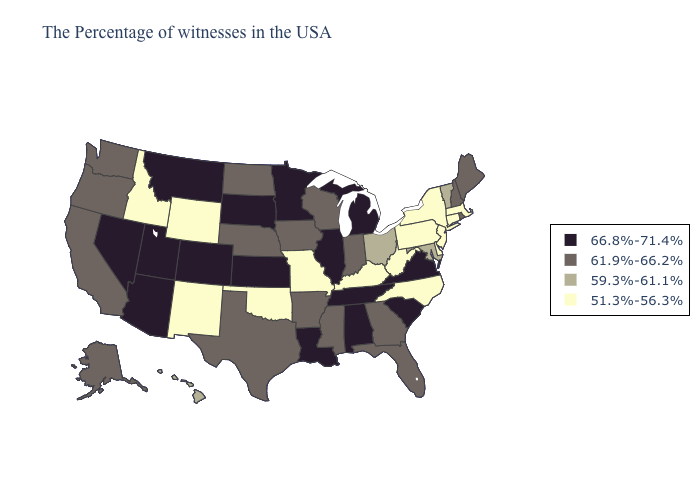Name the states that have a value in the range 51.3%-56.3%?
Be succinct. Massachusetts, Connecticut, New York, New Jersey, Delaware, Pennsylvania, North Carolina, West Virginia, Kentucky, Missouri, Oklahoma, Wyoming, New Mexico, Idaho. Among the states that border Virginia , which have the highest value?
Be succinct. Tennessee. Does the first symbol in the legend represent the smallest category?
Keep it brief. No. Does Pennsylvania have the highest value in the Northeast?
Write a very short answer. No. What is the highest value in the USA?
Keep it brief. 66.8%-71.4%. What is the value of New York?
Answer briefly. 51.3%-56.3%. Name the states that have a value in the range 51.3%-56.3%?
Be succinct. Massachusetts, Connecticut, New York, New Jersey, Delaware, Pennsylvania, North Carolina, West Virginia, Kentucky, Missouri, Oklahoma, Wyoming, New Mexico, Idaho. Which states have the highest value in the USA?
Give a very brief answer. Virginia, South Carolina, Michigan, Alabama, Tennessee, Illinois, Louisiana, Minnesota, Kansas, South Dakota, Colorado, Utah, Montana, Arizona, Nevada. Name the states that have a value in the range 66.8%-71.4%?
Be succinct. Virginia, South Carolina, Michigan, Alabama, Tennessee, Illinois, Louisiana, Minnesota, Kansas, South Dakota, Colorado, Utah, Montana, Arizona, Nevada. Does the map have missing data?
Write a very short answer. No. Among the states that border Utah , which have the lowest value?
Write a very short answer. Wyoming, New Mexico, Idaho. What is the value of South Carolina?
Keep it brief. 66.8%-71.4%. Does Kentucky have the lowest value in the USA?
Short answer required. Yes. What is the lowest value in states that border Minnesota?
Write a very short answer. 61.9%-66.2%. Among the states that border Kansas , which have the lowest value?
Quick response, please. Missouri, Oklahoma. 